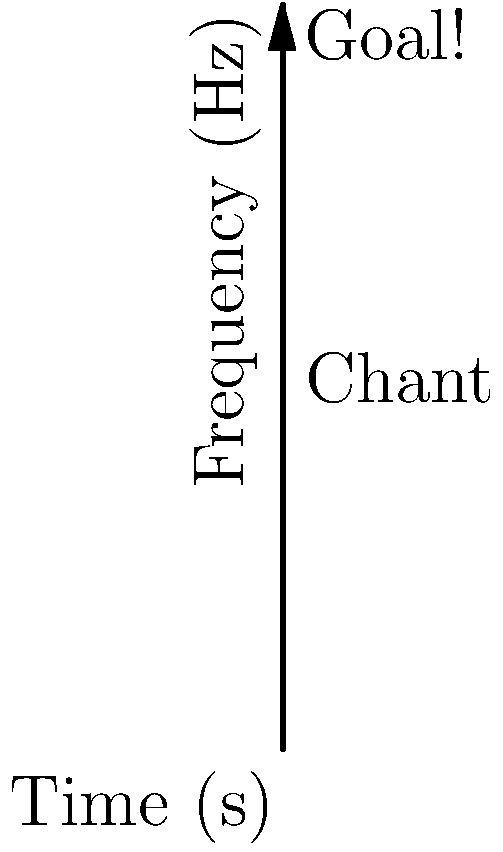Based on the spectrogram of crowd noise during an FC Volendam match, what event likely occurred around the 2-second mark, and what phenomenon can be observed around the 7-second mark? To analyze this spectrogram of crowd noise at an FC Volendam match, we need to interpret the visual representation of sound frequencies over time:

1. The x-axis represents time (in seconds), while the y-axis represents frequency (in Hz).
2. The colors indicate the intensity of sound at each frequency and time point, with red being the most intense and blue the least intense.

3. At the 2-second mark:
   - There's a sudden, intense burst of sound across a wide range of frequencies.
   - This is labeled "Goal!" on the spectrogram.
   - Such a burst is typical of crowd reaction to a goal being scored.

4. Around the 7-second mark:
   - There's a sustained pattern of sound at specific frequencies.
   - This is labeled "Chant" on the spectrogram.
   - The regular pattern suggests rhythmic crowd chanting, a common occurrence in football matches.

5. The chant appears to have a fundamental frequency around 250 Hz, with harmonics visible at multiples of this frequency.

Given the persona of a longtime FC Volendam fan and local historian, this spectrogram likely represents a familiar and exciting moment in a match, with the crowd's reaction to a goal followed by celebratory chanting.
Answer: Goal scored at 2 seconds; crowd chanting at 7 seconds. 